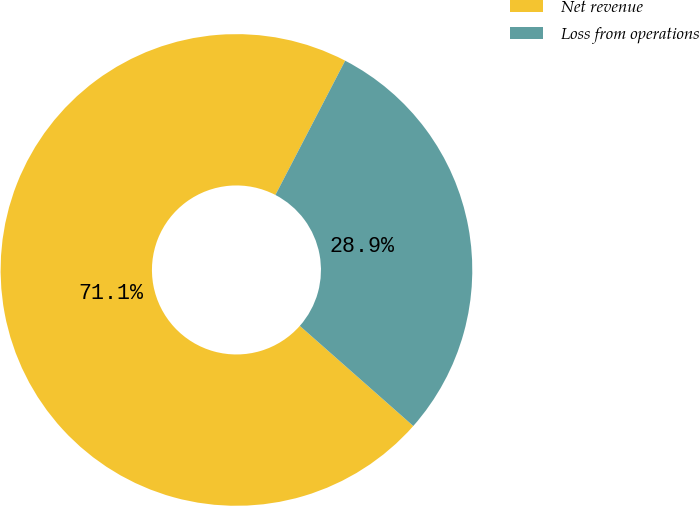Convert chart. <chart><loc_0><loc_0><loc_500><loc_500><pie_chart><fcel>Net revenue<fcel>Loss from operations<nl><fcel>71.12%<fcel>28.88%<nl></chart> 